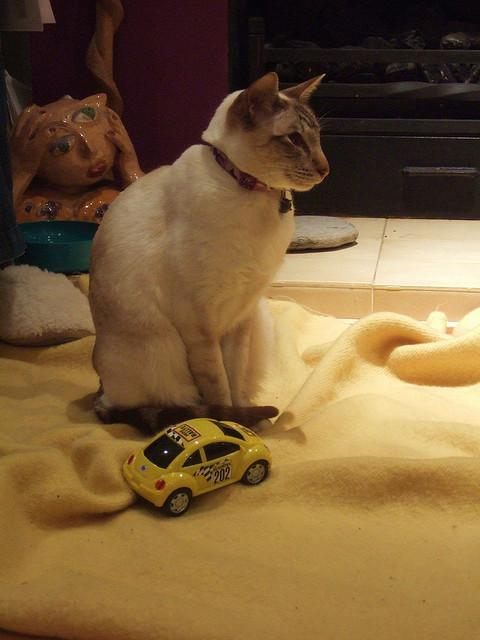What room is it? bedroom 